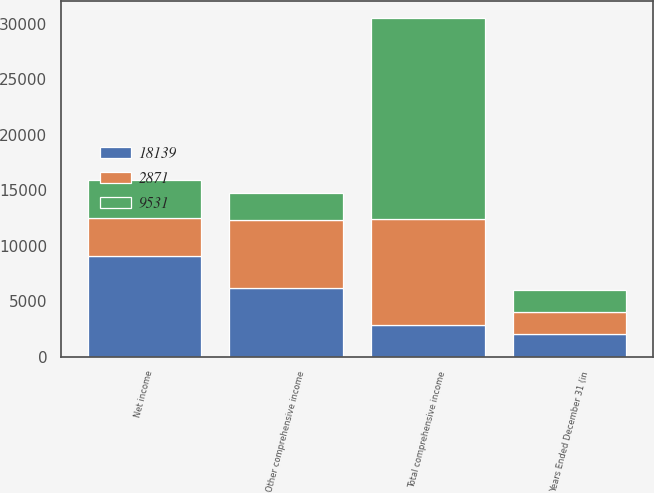Convert chart to OTSL. <chart><loc_0><loc_0><loc_500><loc_500><stacked_bar_chart><ecel><fcel>Years Ended December 31 (in<fcel>Net income<fcel>Other comprehensive income<fcel>Total comprehensive income<nl><fcel>18139<fcel>2013<fcel>9085<fcel>6214<fcel>2871<nl><fcel>2871<fcel>2012<fcel>3438<fcel>6093<fcel>9531<nl><fcel>9531<fcel>2011<fcel>3438<fcel>2483<fcel>18139<nl></chart> 